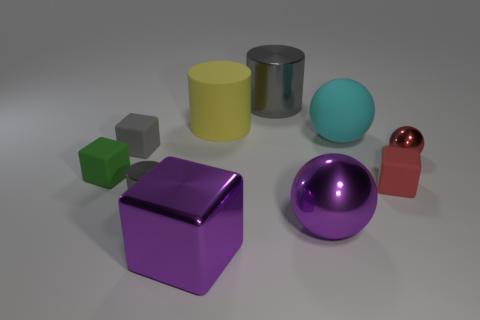The matte thing that is the same color as the tiny cylinder is what size?
Offer a terse response. Small. Does the large metallic cylinder have the same color as the tiny metal cylinder?
Your answer should be compact. Yes. There is a metal object that is both on the left side of the big yellow matte cylinder and behind the shiny block; how big is it?
Provide a short and direct response. Small. Do the small cylinder and the gray cylinder that is on the right side of the big cube have the same material?
Keep it short and to the point. Yes. Is the number of big purple shiny cubes behind the big cyan sphere less than the number of gray blocks that are in front of the big gray cylinder?
Provide a succinct answer. Yes. There is a big purple object that is behind the shiny cube; what material is it?
Offer a very short reply. Metal. What color is the matte object that is on the right side of the big yellow cylinder and behind the small shiny sphere?
Ensure brevity in your answer.  Cyan. How many other objects are there of the same color as the large shiny cylinder?
Provide a succinct answer. 2. The big metallic object that is behind the small green rubber block is what color?
Your answer should be compact. Gray. Are there any purple matte cubes that have the same size as the rubber ball?
Offer a very short reply. No. 